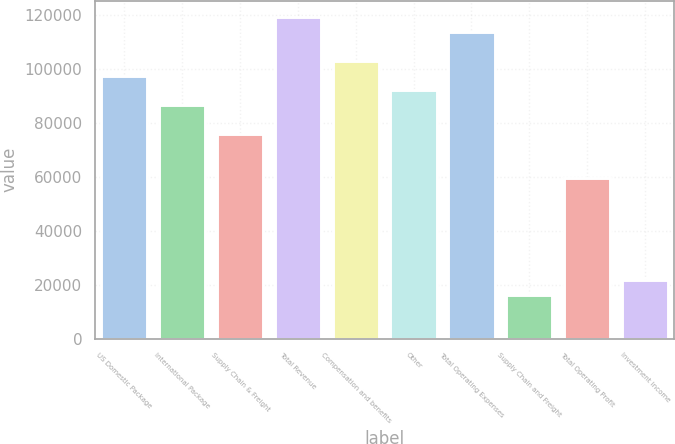<chart> <loc_0><loc_0><loc_500><loc_500><bar_chart><fcel>US Domestic Package<fcel>International Package<fcel>Supply Chain & Freight<fcel>Total Revenue<fcel>Compensation and benefits<fcel>Other<fcel>Total Operating Expenses<fcel>Supply Chain and Freight<fcel>Total Operating Profit<fcel>Investment income<nl><fcel>97428<fcel>86602.8<fcel>75777.5<fcel>119078<fcel>102841<fcel>92015.4<fcel>113666<fcel>16238.7<fcel>59539.7<fcel>21651.3<nl></chart> 